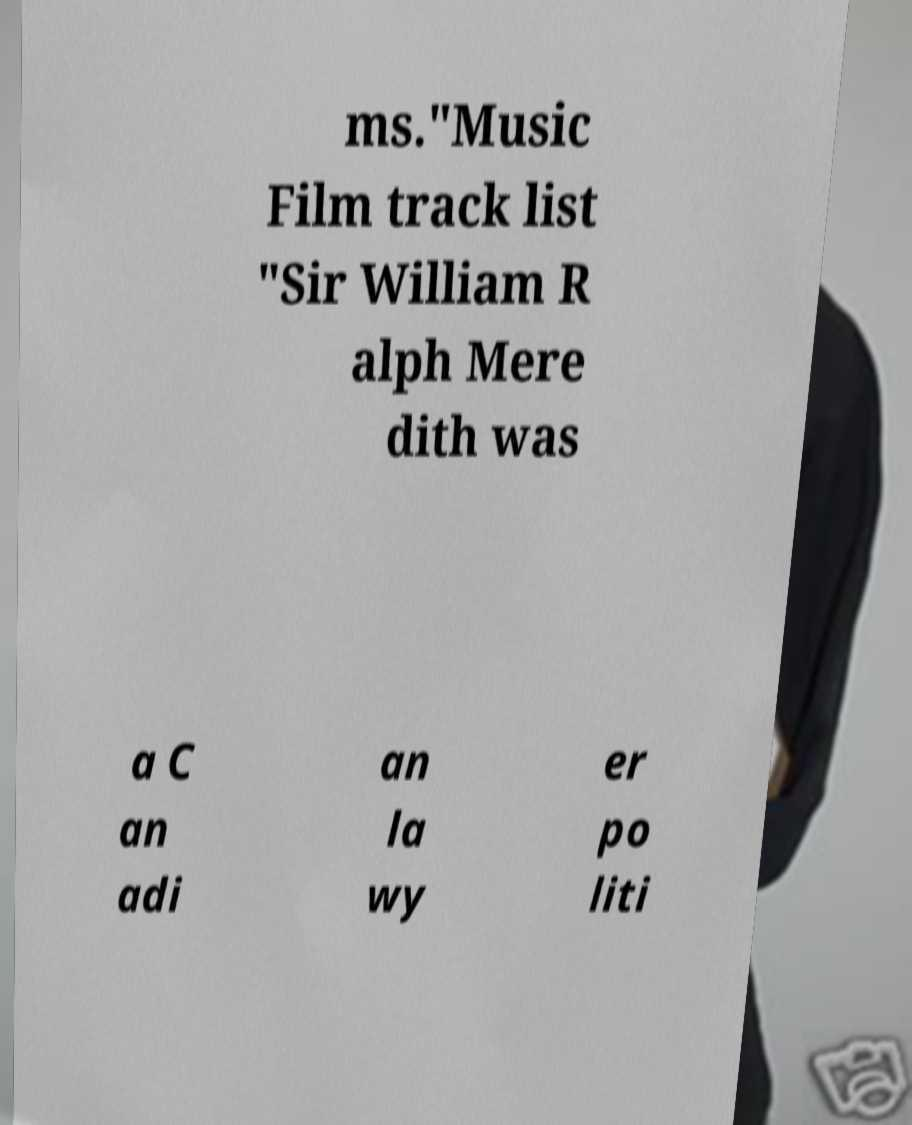Could you extract and type out the text from this image? ms."Music Film track list "Sir William R alph Mere dith was a C an adi an la wy er po liti 